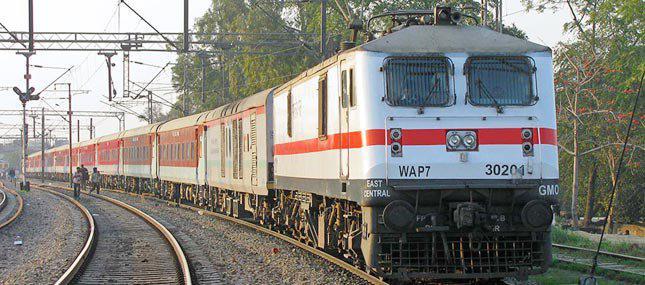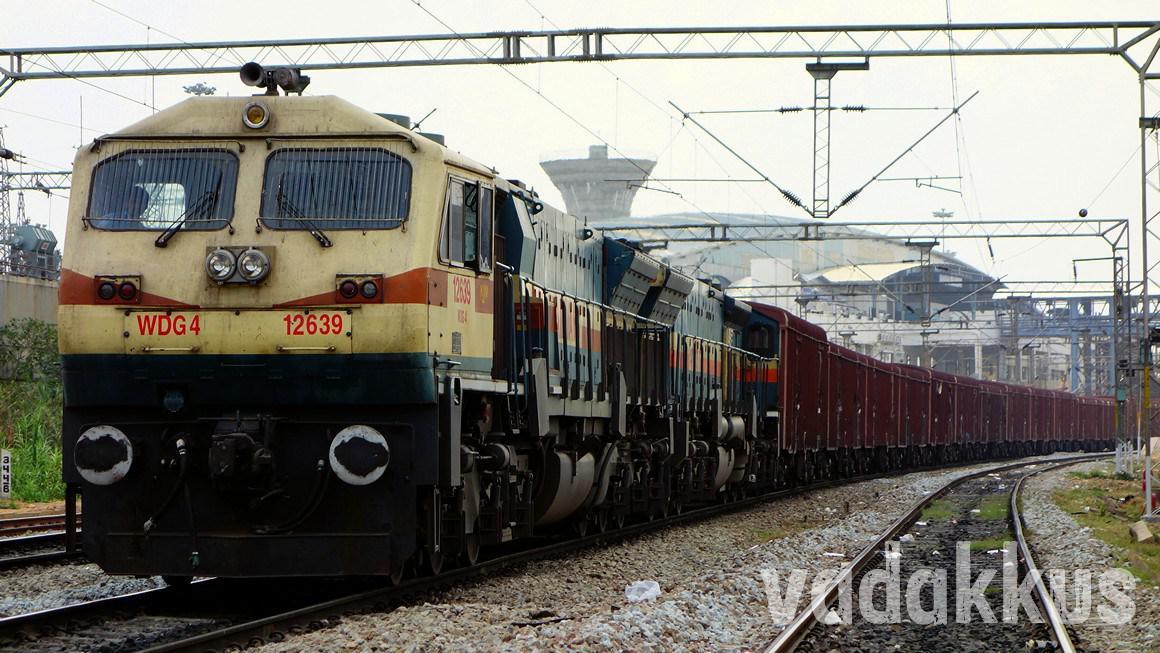The first image is the image on the left, the second image is the image on the right. Assess this claim about the two images: "A green train, with yellow trim and two square end windows, is sitting on the tracks on a sunny day.". Correct or not? Answer yes or no. No. 